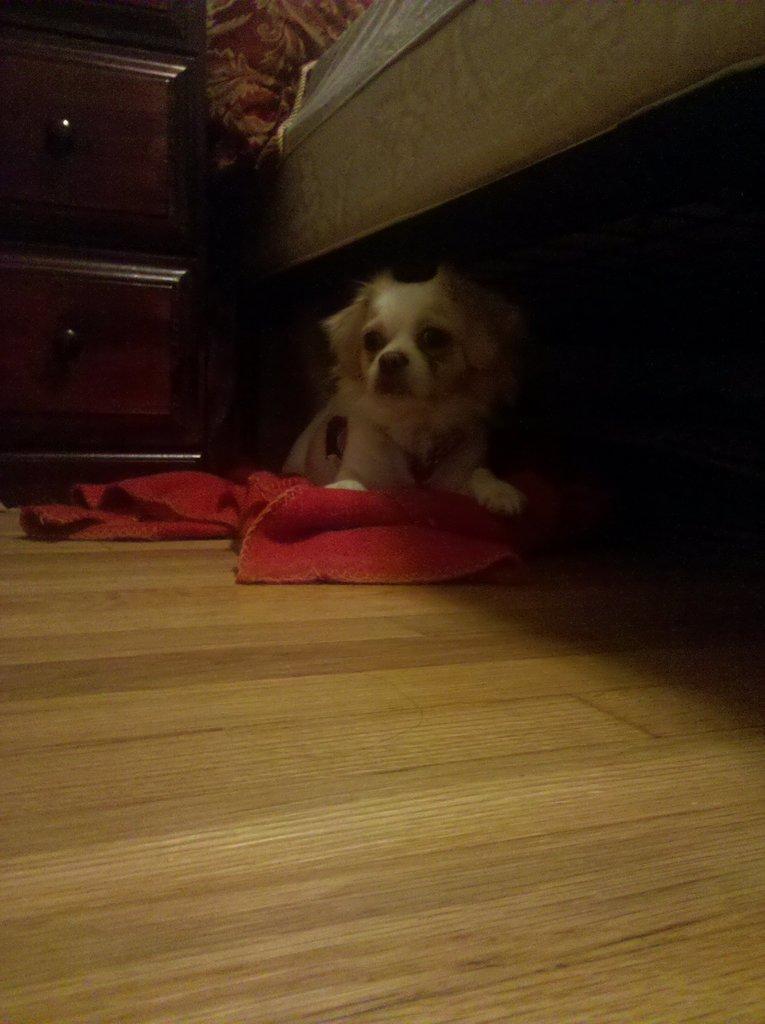Could you give a brief overview of what you see in this image? In this image there is a wooden floor towards the bottom of the image, there is a cloth on the wooden floor, there is a dog on the cloth, there is a cupboard towards the left of the image, there is an object towards the top of the image that looks like a bed. 